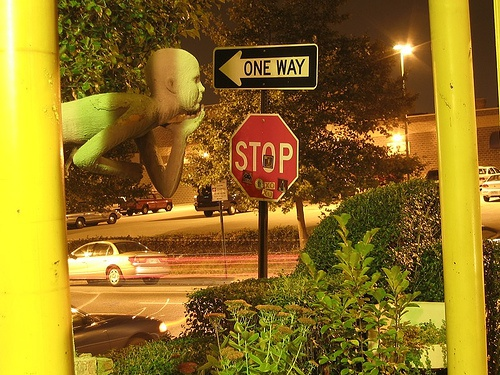Describe the objects in this image and their specific colors. I can see stop sign in yellow, brown, and maroon tones, car in yellow, orange, khaki, brown, and beige tones, car in yellow, maroon, brown, and orange tones, car in yellow, maroon, brown, and black tones, and truck in yellow, maroon, brown, and black tones in this image. 